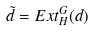Convert formula to latex. <formula><loc_0><loc_0><loc_500><loc_500>\tilde { d } = E x t _ { H } ^ { G } ( d )</formula> 